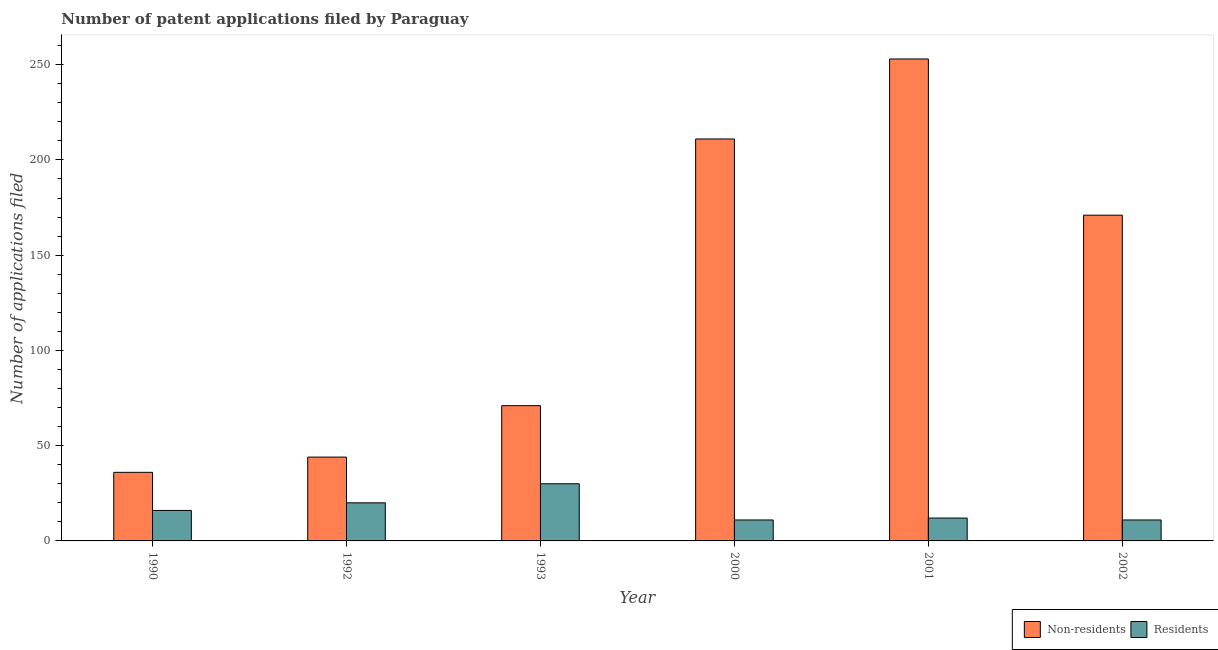Are the number of bars on each tick of the X-axis equal?
Your answer should be compact. Yes. How many bars are there on the 4th tick from the right?
Offer a very short reply. 2. In how many cases, is the number of bars for a given year not equal to the number of legend labels?
Give a very brief answer. 0. What is the number of patent applications by residents in 2000?
Give a very brief answer. 11. Across all years, what is the maximum number of patent applications by non residents?
Your answer should be very brief. 253. Across all years, what is the minimum number of patent applications by non residents?
Offer a very short reply. 36. In which year was the number of patent applications by residents maximum?
Your response must be concise. 1993. What is the total number of patent applications by residents in the graph?
Give a very brief answer. 100. What is the difference between the number of patent applications by residents in 1992 and that in 2001?
Give a very brief answer. 8. What is the difference between the number of patent applications by residents in 1990 and the number of patent applications by non residents in 1993?
Offer a terse response. -14. What is the average number of patent applications by non residents per year?
Offer a terse response. 131. What is the ratio of the number of patent applications by residents in 1990 to that in 1992?
Keep it short and to the point. 0.8. Is the number of patent applications by non residents in 1992 less than that in 1993?
Keep it short and to the point. Yes. Is the difference between the number of patent applications by residents in 1992 and 2000 greater than the difference between the number of patent applications by non residents in 1992 and 2000?
Provide a succinct answer. No. What is the difference between the highest and the lowest number of patent applications by residents?
Keep it short and to the point. 19. Is the sum of the number of patent applications by residents in 1993 and 2002 greater than the maximum number of patent applications by non residents across all years?
Offer a very short reply. Yes. What does the 1st bar from the left in 2002 represents?
Provide a succinct answer. Non-residents. What does the 2nd bar from the right in 1993 represents?
Ensure brevity in your answer.  Non-residents. What is the difference between two consecutive major ticks on the Y-axis?
Provide a succinct answer. 50. Does the graph contain any zero values?
Your answer should be compact. No. Where does the legend appear in the graph?
Provide a short and direct response. Bottom right. What is the title of the graph?
Give a very brief answer. Number of patent applications filed by Paraguay. What is the label or title of the X-axis?
Provide a succinct answer. Year. What is the label or title of the Y-axis?
Provide a succinct answer. Number of applications filed. What is the Number of applications filed in Non-residents in 1990?
Provide a short and direct response. 36. What is the Number of applications filed in Non-residents in 1992?
Ensure brevity in your answer.  44. What is the Number of applications filed in Residents in 1992?
Offer a terse response. 20. What is the Number of applications filed of Residents in 1993?
Offer a terse response. 30. What is the Number of applications filed of Non-residents in 2000?
Give a very brief answer. 211. What is the Number of applications filed of Non-residents in 2001?
Make the answer very short. 253. What is the Number of applications filed in Non-residents in 2002?
Give a very brief answer. 171. What is the Number of applications filed in Residents in 2002?
Your response must be concise. 11. Across all years, what is the maximum Number of applications filed in Non-residents?
Your response must be concise. 253. Across all years, what is the minimum Number of applications filed of Residents?
Your answer should be very brief. 11. What is the total Number of applications filed in Non-residents in the graph?
Your answer should be very brief. 786. What is the total Number of applications filed of Residents in the graph?
Offer a terse response. 100. What is the difference between the Number of applications filed in Non-residents in 1990 and that in 1992?
Your answer should be very brief. -8. What is the difference between the Number of applications filed in Non-residents in 1990 and that in 1993?
Ensure brevity in your answer.  -35. What is the difference between the Number of applications filed in Non-residents in 1990 and that in 2000?
Keep it short and to the point. -175. What is the difference between the Number of applications filed of Residents in 1990 and that in 2000?
Make the answer very short. 5. What is the difference between the Number of applications filed in Non-residents in 1990 and that in 2001?
Your answer should be very brief. -217. What is the difference between the Number of applications filed in Non-residents in 1990 and that in 2002?
Offer a terse response. -135. What is the difference between the Number of applications filed in Non-residents in 1992 and that in 1993?
Your response must be concise. -27. What is the difference between the Number of applications filed in Residents in 1992 and that in 1993?
Provide a succinct answer. -10. What is the difference between the Number of applications filed of Non-residents in 1992 and that in 2000?
Your response must be concise. -167. What is the difference between the Number of applications filed in Residents in 1992 and that in 2000?
Your answer should be very brief. 9. What is the difference between the Number of applications filed in Non-residents in 1992 and that in 2001?
Give a very brief answer. -209. What is the difference between the Number of applications filed in Residents in 1992 and that in 2001?
Provide a short and direct response. 8. What is the difference between the Number of applications filed of Non-residents in 1992 and that in 2002?
Offer a very short reply. -127. What is the difference between the Number of applications filed in Residents in 1992 and that in 2002?
Your answer should be very brief. 9. What is the difference between the Number of applications filed in Non-residents in 1993 and that in 2000?
Make the answer very short. -140. What is the difference between the Number of applications filed in Residents in 1993 and that in 2000?
Your answer should be compact. 19. What is the difference between the Number of applications filed of Non-residents in 1993 and that in 2001?
Offer a very short reply. -182. What is the difference between the Number of applications filed in Residents in 1993 and that in 2001?
Your response must be concise. 18. What is the difference between the Number of applications filed in Non-residents in 1993 and that in 2002?
Offer a terse response. -100. What is the difference between the Number of applications filed of Non-residents in 2000 and that in 2001?
Offer a terse response. -42. What is the difference between the Number of applications filed in Residents in 2000 and that in 2002?
Your answer should be very brief. 0. What is the difference between the Number of applications filed of Non-residents in 2001 and that in 2002?
Your answer should be compact. 82. What is the difference between the Number of applications filed in Residents in 2001 and that in 2002?
Provide a short and direct response. 1. What is the difference between the Number of applications filed in Non-residents in 1990 and the Number of applications filed in Residents in 1993?
Your response must be concise. 6. What is the difference between the Number of applications filed in Non-residents in 1990 and the Number of applications filed in Residents in 2000?
Offer a very short reply. 25. What is the difference between the Number of applications filed in Non-residents in 1990 and the Number of applications filed in Residents in 2001?
Ensure brevity in your answer.  24. What is the difference between the Number of applications filed in Non-residents in 1990 and the Number of applications filed in Residents in 2002?
Make the answer very short. 25. What is the difference between the Number of applications filed of Non-residents in 1992 and the Number of applications filed of Residents in 2000?
Provide a short and direct response. 33. What is the difference between the Number of applications filed of Non-residents in 1992 and the Number of applications filed of Residents in 2001?
Offer a terse response. 32. What is the difference between the Number of applications filed of Non-residents in 1993 and the Number of applications filed of Residents in 2001?
Offer a very short reply. 59. What is the difference between the Number of applications filed of Non-residents in 1993 and the Number of applications filed of Residents in 2002?
Keep it short and to the point. 60. What is the difference between the Number of applications filed in Non-residents in 2000 and the Number of applications filed in Residents in 2001?
Offer a terse response. 199. What is the difference between the Number of applications filed of Non-residents in 2000 and the Number of applications filed of Residents in 2002?
Your answer should be compact. 200. What is the difference between the Number of applications filed in Non-residents in 2001 and the Number of applications filed in Residents in 2002?
Your answer should be very brief. 242. What is the average Number of applications filed of Non-residents per year?
Your answer should be compact. 131. What is the average Number of applications filed of Residents per year?
Provide a succinct answer. 16.67. In the year 1990, what is the difference between the Number of applications filed in Non-residents and Number of applications filed in Residents?
Your answer should be compact. 20. In the year 1993, what is the difference between the Number of applications filed of Non-residents and Number of applications filed of Residents?
Your answer should be compact. 41. In the year 2001, what is the difference between the Number of applications filed in Non-residents and Number of applications filed in Residents?
Provide a succinct answer. 241. In the year 2002, what is the difference between the Number of applications filed of Non-residents and Number of applications filed of Residents?
Your response must be concise. 160. What is the ratio of the Number of applications filed of Non-residents in 1990 to that in 1992?
Provide a short and direct response. 0.82. What is the ratio of the Number of applications filed of Residents in 1990 to that in 1992?
Ensure brevity in your answer.  0.8. What is the ratio of the Number of applications filed in Non-residents in 1990 to that in 1993?
Offer a very short reply. 0.51. What is the ratio of the Number of applications filed in Residents in 1990 to that in 1993?
Your answer should be compact. 0.53. What is the ratio of the Number of applications filed of Non-residents in 1990 to that in 2000?
Offer a terse response. 0.17. What is the ratio of the Number of applications filed of Residents in 1990 to that in 2000?
Provide a short and direct response. 1.45. What is the ratio of the Number of applications filed in Non-residents in 1990 to that in 2001?
Your response must be concise. 0.14. What is the ratio of the Number of applications filed of Non-residents in 1990 to that in 2002?
Your answer should be compact. 0.21. What is the ratio of the Number of applications filed of Residents in 1990 to that in 2002?
Your response must be concise. 1.45. What is the ratio of the Number of applications filed in Non-residents in 1992 to that in 1993?
Give a very brief answer. 0.62. What is the ratio of the Number of applications filed of Non-residents in 1992 to that in 2000?
Keep it short and to the point. 0.21. What is the ratio of the Number of applications filed of Residents in 1992 to that in 2000?
Give a very brief answer. 1.82. What is the ratio of the Number of applications filed in Non-residents in 1992 to that in 2001?
Keep it short and to the point. 0.17. What is the ratio of the Number of applications filed of Non-residents in 1992 to that in 2002?
Provide a short and direct response. 0.26. What is the ratio of the Number of applications filed in Residents in 1992 to that in 2002?
Offer a very short reply. 1.82. What is the ratio of the Number of applications filed of Non-residents in 1993 to that in 2000?
Your answer should be very brief. 0.34. What is the ratio of the Number of applications filed of Residents in 1993 to that in 2000?
Ensure brevity in your answer.  2.73. What is the ratio of the Number of applications filed in Non-residents in 1993 to that in 2001?
Keep it short and to the point. 0.28. What is the ratio of the Number of applications filed of Non-residents in 1993 to that in 2002?
Offer a very short reply. 0.42. What is the ratio of the Number of applications filed in Residents in 1993 to that in 2002?
Give a very brief answer. 2.73. What is the ratio of the Number of applications filed of Non-residents in 2000 to that in 2001?
Ensure brevity in your answer.  0.83. What is the ratio of the Number of applications filed of Non-residents in 2000 to that in 2002?
Your answer should be compact. 1.23. What is the ratio of the Number of applications filed in Residents in 2000 to that in 2002?
Your answer should be compact. 1. What is the ratio of the Number of applications filed in Non-residents in 2001 to that in 2002?
Ensure brevity in your answer.  1.48. What is the ratio of the Number of applications filed in Residents in 2001 to that in 2002?
Give a very brief answer. 1.09. What is the difference between the highest and the second highest Number of applications filed in Residents?
Offer a terse response. 10. What is the difference between the highest and the lowest Number of applications filed in Non-residents?
Make the answer very short. 217. What is the difference between the highest and the lowest Number of applications filed in Residents?
Make the answer very short. 19. 